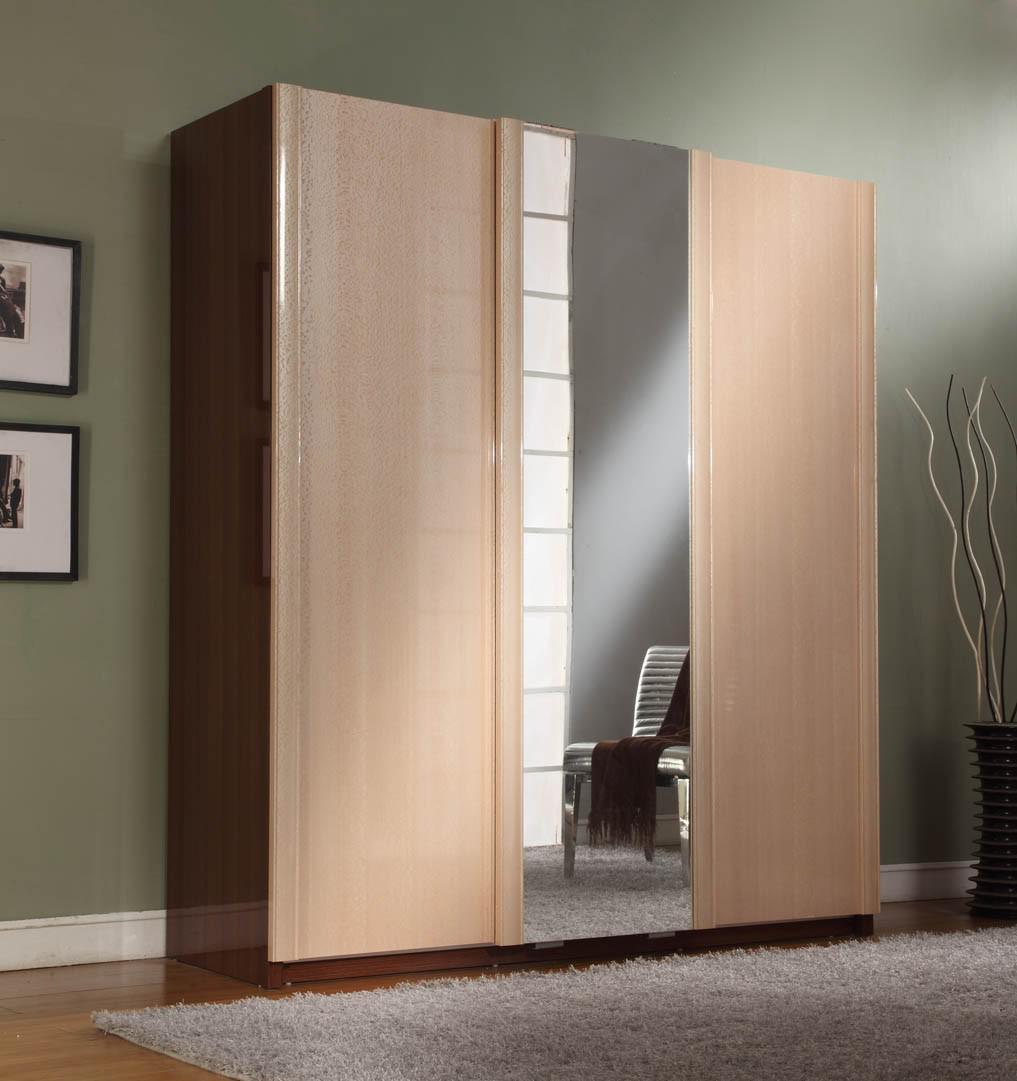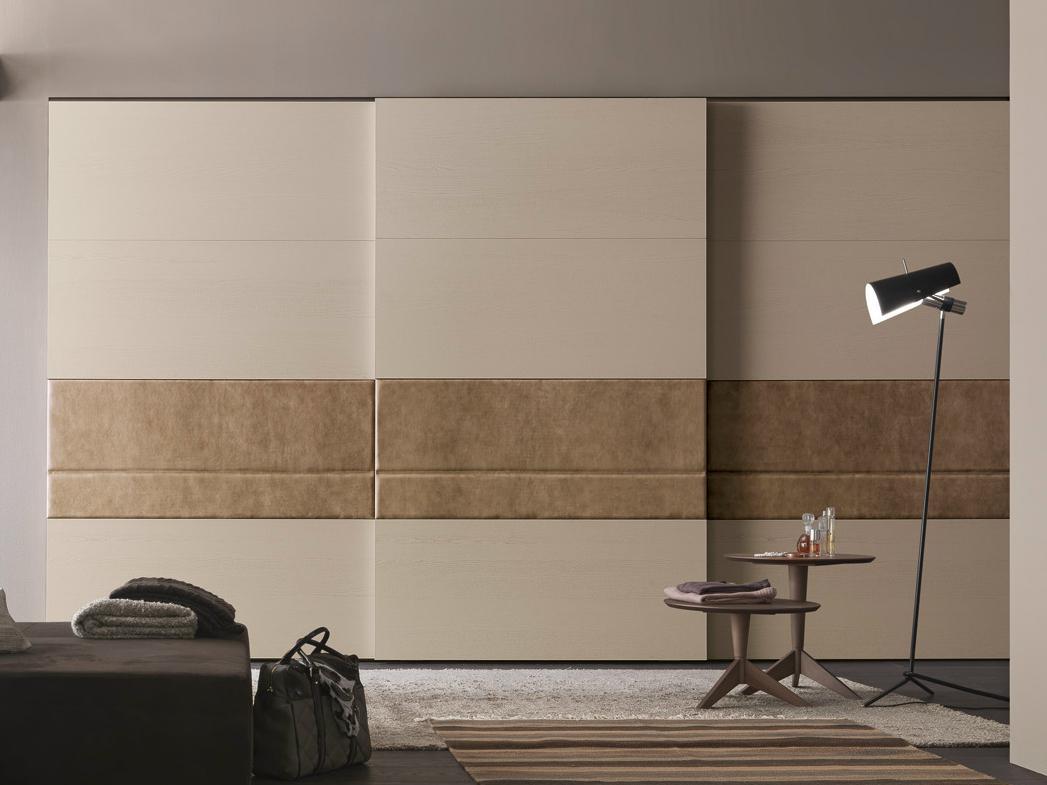The first image is the image on the left, the second image is the image on the right. Considering the images on both sides, is "In one of the images there are clothes visible inside the partially open closet." valid? Answer yes or no. No. The first image is the image on the left, the second image is the image on the right. For the images displayed, is the sentence "A rug covers the floor in at least one of the images." factually correct? Answer yes or no. Yes. 